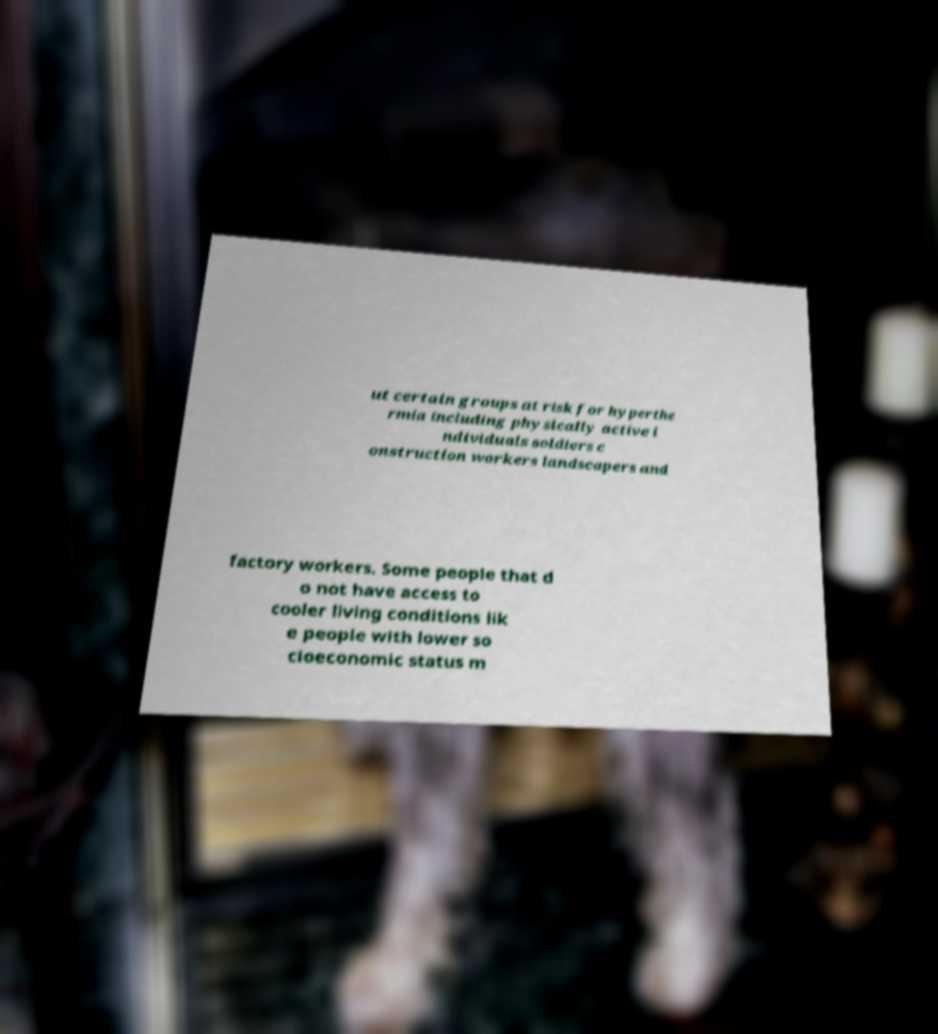Please read and relay the text visible in this image. What does it say? ut certain groups at risk for hyperthe rmia including physically active i ndividuals soldiers c onstruction workers landscapers and factory workers. Some people that d o not have access to cooler living conditions lik e people with lower so cioeconomic status m 